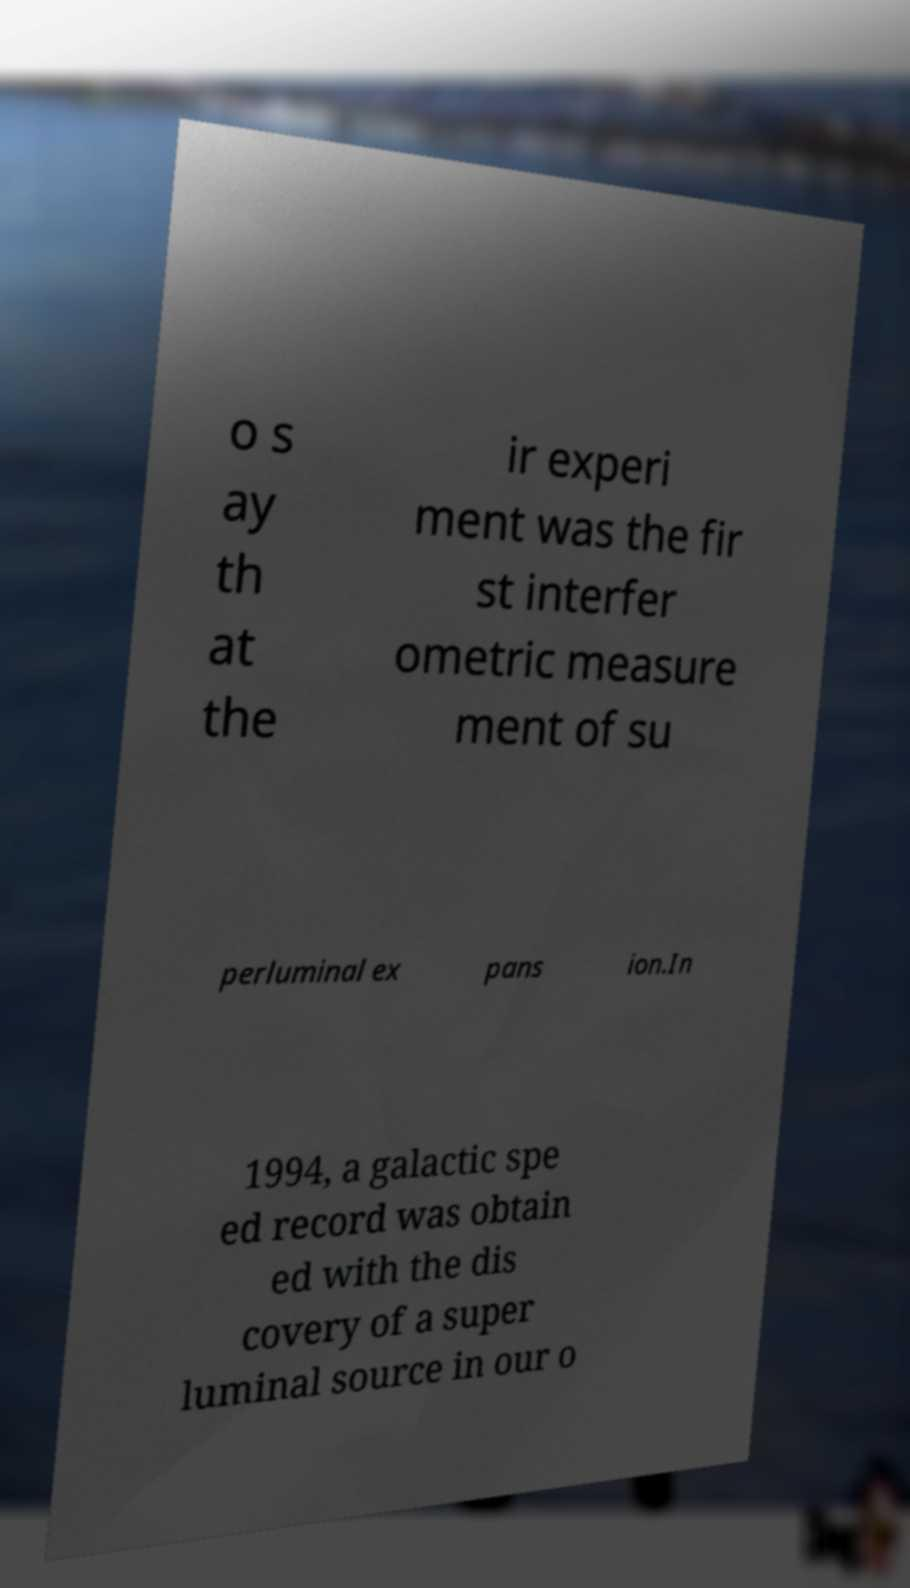I need the written content from this picture converted into text. Can you do that? o s ay th at the ir experi ment was the fir st interfer ometric measure ment of su perluminal ex pans ion.In 1994, a galactic spe ed record was obtain ed with the dis covery of a super luminal source in our o 